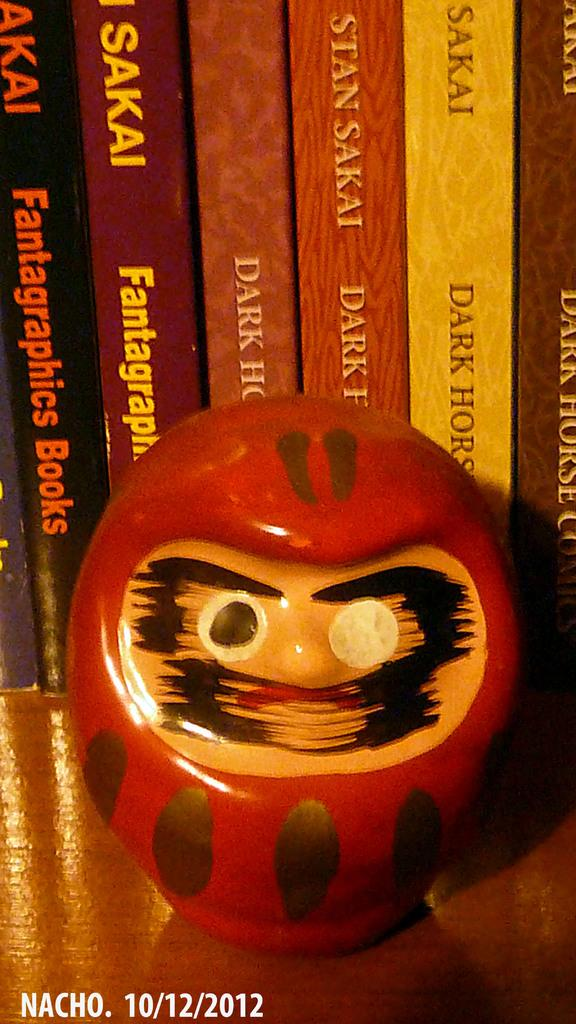Provide a one-sentence caption for the provided image. A SMALL RED SCULPTURE WITH A MISSING PUPIL IN FRONT OF BOOKS BY SAKAI. DATE 10/12/2012. 